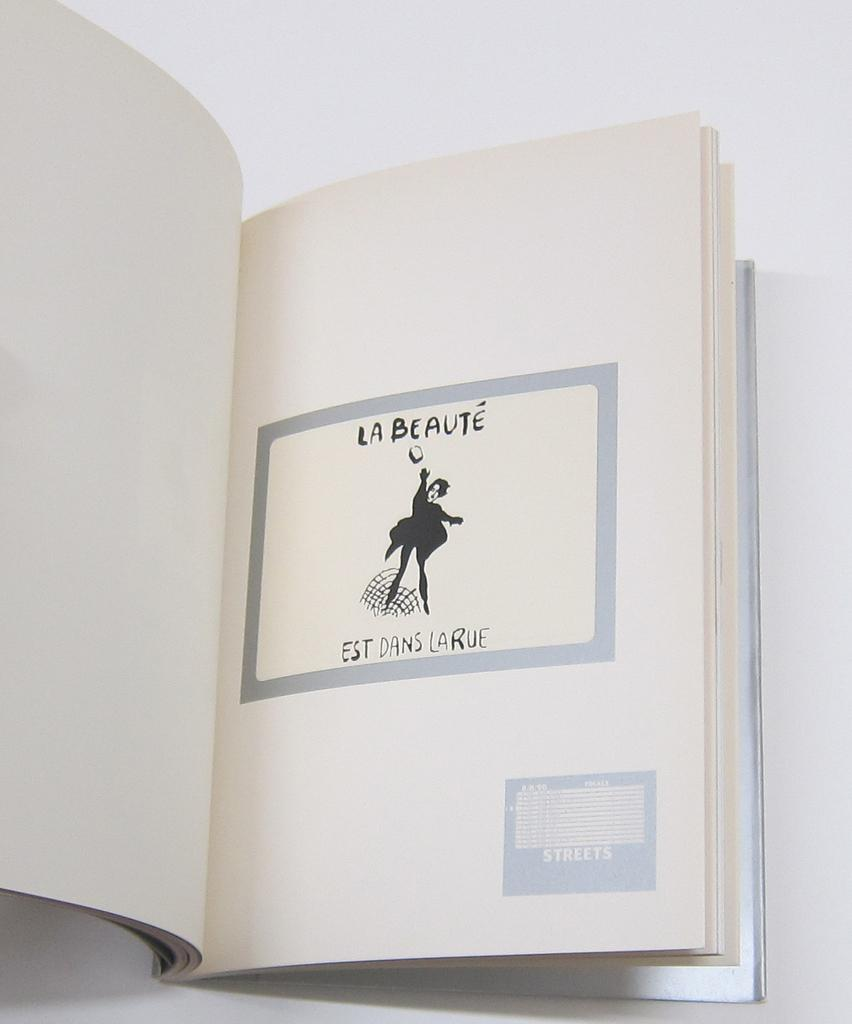Provide a one-sentence caption for the provided image. La Beaute is written over a black and white drawing of a person. 